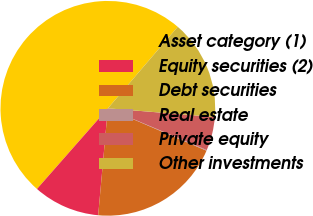Convert chart to OTSL. <chart><loc_0><loc_0><loc_500><loc_500><pie_chart><fcel>Asset category (1)<fcel>Equity securities (2)<fcel>Debt securities<fcel>Real estate<fcel>Private equity<fcel>Other investments<nl><fcel>49.8%<fcel>10.04%<fcel>19.98%<fcel>0.1%<fcel>5.07%<fcel>15.01%<nl></chart> 